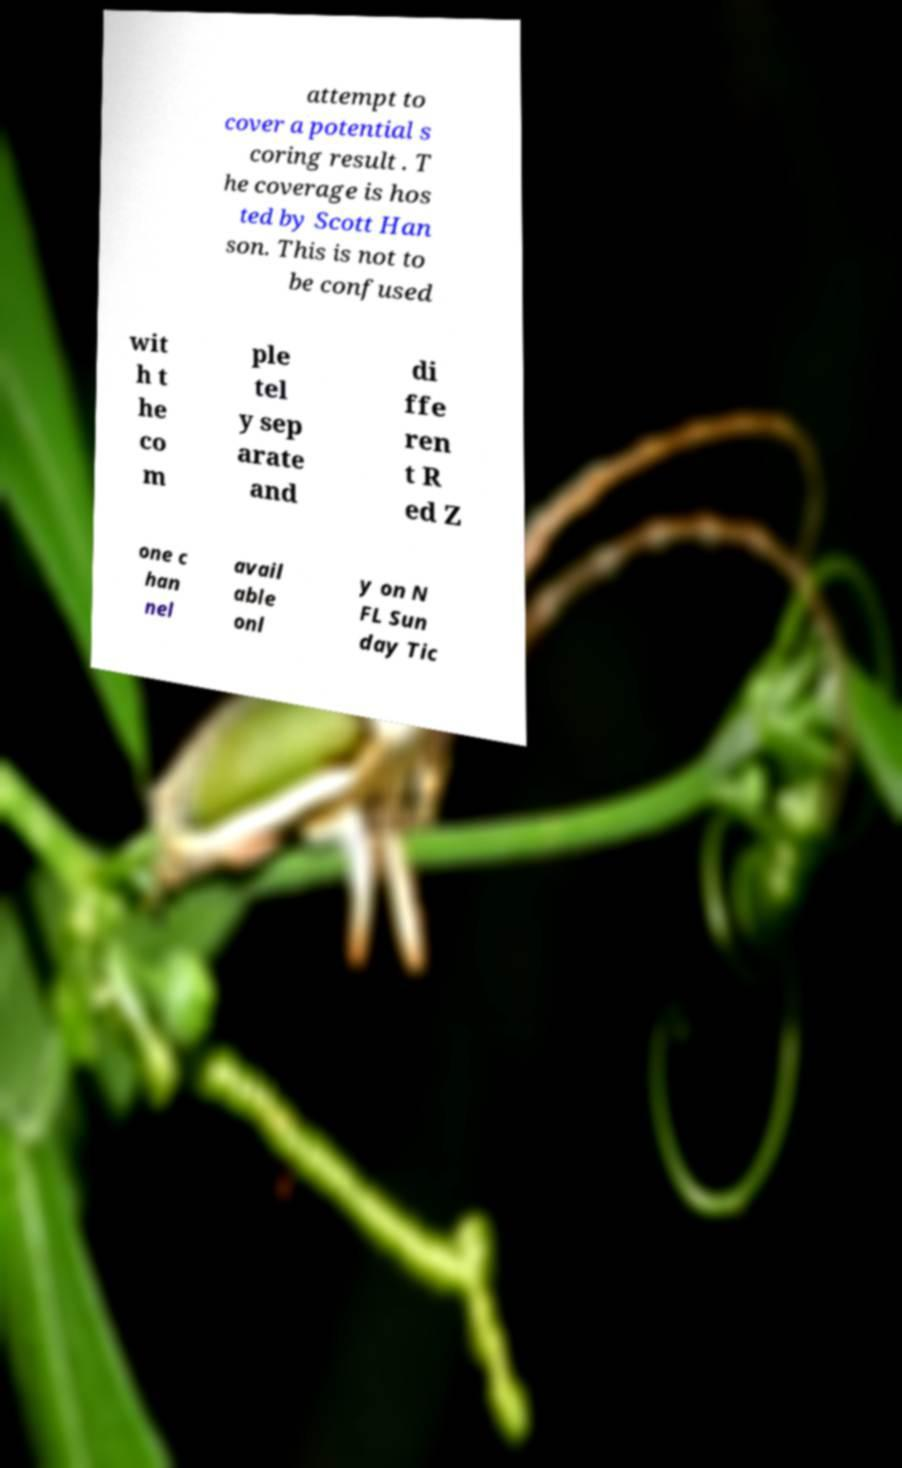Could you extract and type out the text from this image? attempt to cover a potential s coring result . T he coverage is hos ted by Scott Han son. This is not to be confused wit h t he co m ple tel y sep arate and di ffe ren t R ed Z one c han nel avail able onl y on N FL Sun day Tic 